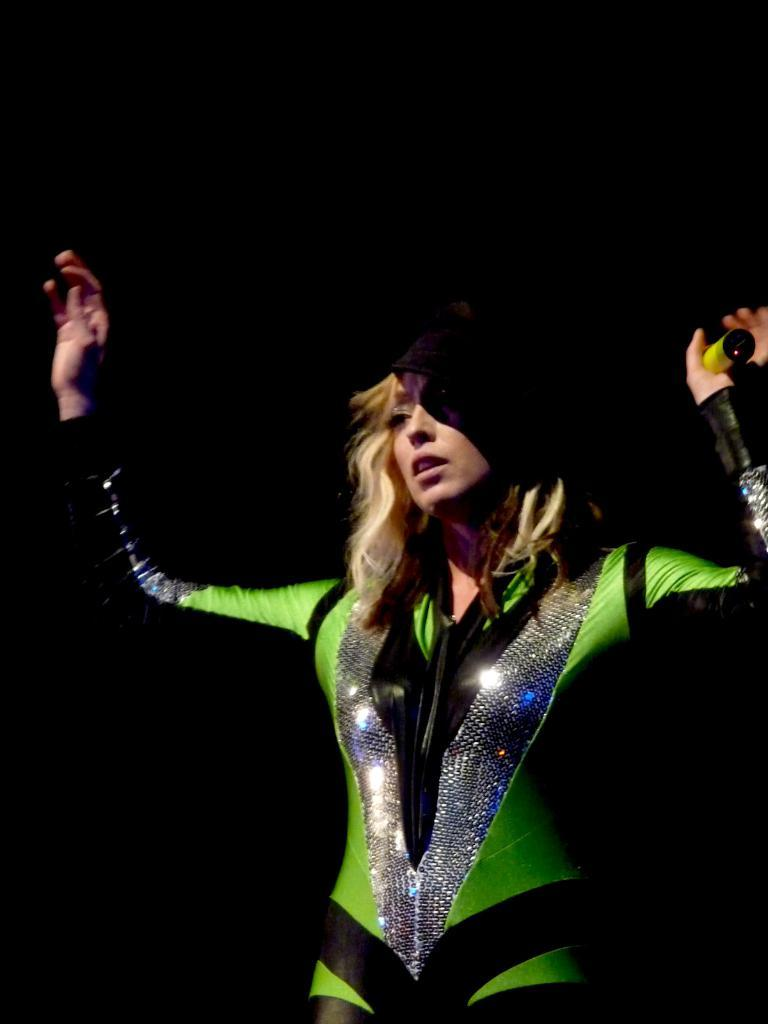Who is the main subject in the image? There is a woman in the image. What is the woman wearing? The woman is wearing a costume. What is the woman holding in her hand? The woman is holding an object in her hand. What is the color of the background in the image? The background of the image is black. What type of vegetable is the woman holding in her hand? The woman is not holding a vegetable in her hand; she is holding an object. What thrill does the woman experience while wearing the costume? There is no information about the woman's emotions or experiences in the image, so we cannot determine if she is experiencing any thrill. 